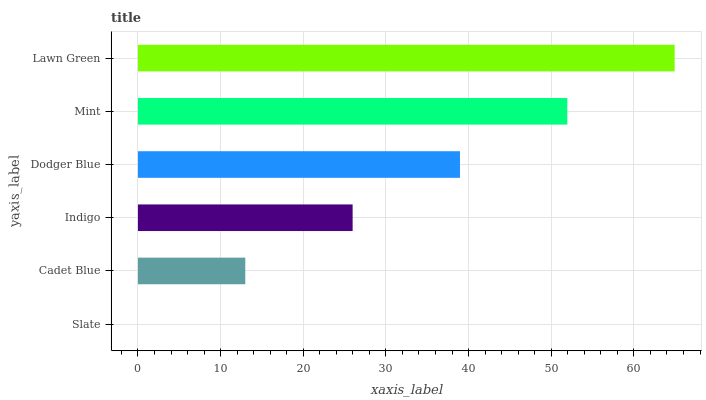Is Slate the minimum?
Answer yes or no. Yes. Is Lawn Green the maximum?
Answer yes or no. Yes. Is Cadet Blue the minimum?
Answer yes or no. No. Is Cadet Blue the maximum?
Answer yes or no. No. Is Cadet Blue greater than Slate?
Answer yes or no. Yes. Is Slate less than Cadet Blue?
Answer yes or no. Yes. Is Slate greater than Cadet Blue?
Answer yes or no. No. Is Cadet Blue less than Slate?
Answer yes or no. No. Is Dodger Blue the high median?
Answer yes or no. Yes. Is Indigo the low median?
Answer yes or no. Yes. Is Slate the high median?
Answer yes or no. No. Is Cadet Blue the low median?
Answer yes or no. No. 